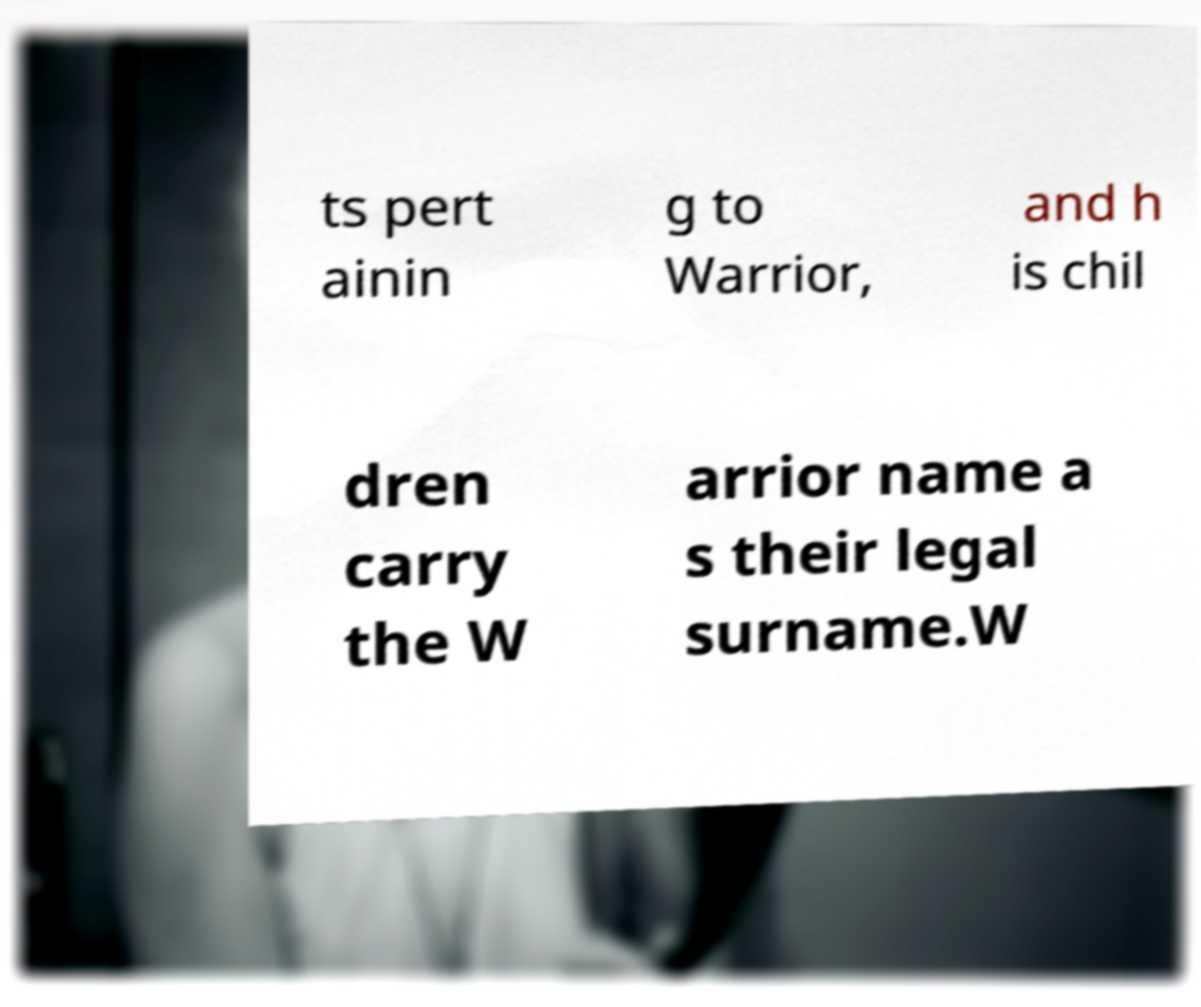For documentation purposes, I need the text within this image transcribed. Could you provide that? ts pert ainin g to Warrior, and h is chil dren carry the W arrior name a s their legal surname.W 